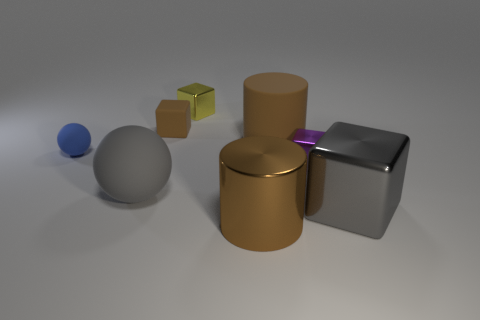Subtract 1 cubes. How many cubes are left? 3 Add 2 tiny metal objects. How many objects exist? 10 Subtract all cylinders. How many objects are left? 6 Subtract all gray metallic blocks. Subtract all large gray metal things. How many objects are left? 6 Add 4 yellow things. How many yellow things are left? 5 Add 2 brown rubber blocks. How many brown rubber blocks exist? 3 Subtract 0 red spheres. How many objects are left? 8 